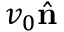<formula> <loc_0><loc_0><loc_500><loc_500>v _ { 0 } \hat { \mathbf n }</formula> 